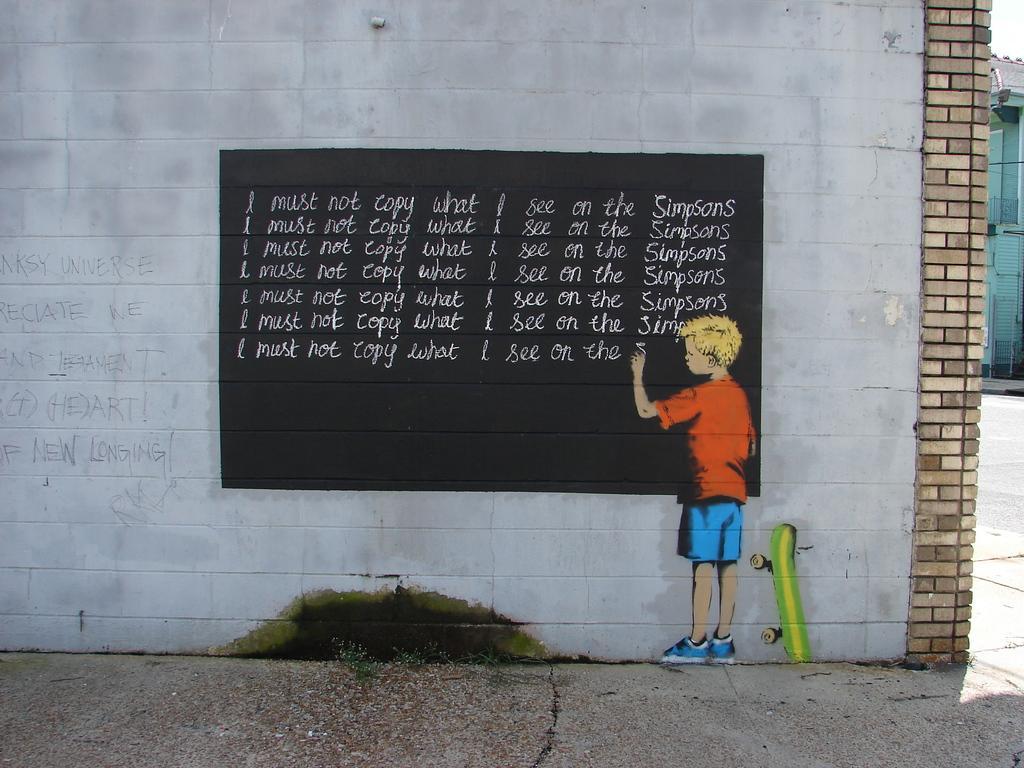Please provide a concise description of this image. In this image I can see the wall painting. In the painting I can see the person wearing the blue and orange color dress. To the side there are skate wheels. I can see the person is writing the text on the black surface. To the side I can see the house and the sky. 